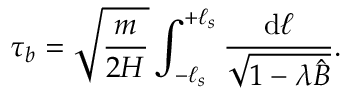<formula> <loc_0><loc_0><loc_500><loc_500>\tau _ { b } = \sqrt { \frac { m } { 2 H } } \int _ { - \ell _ { s } } ^ { + \ell _ { s } } \frac { d \ell } { \sqrt { 1 - \lambda \hat { B } } } .</formula> 